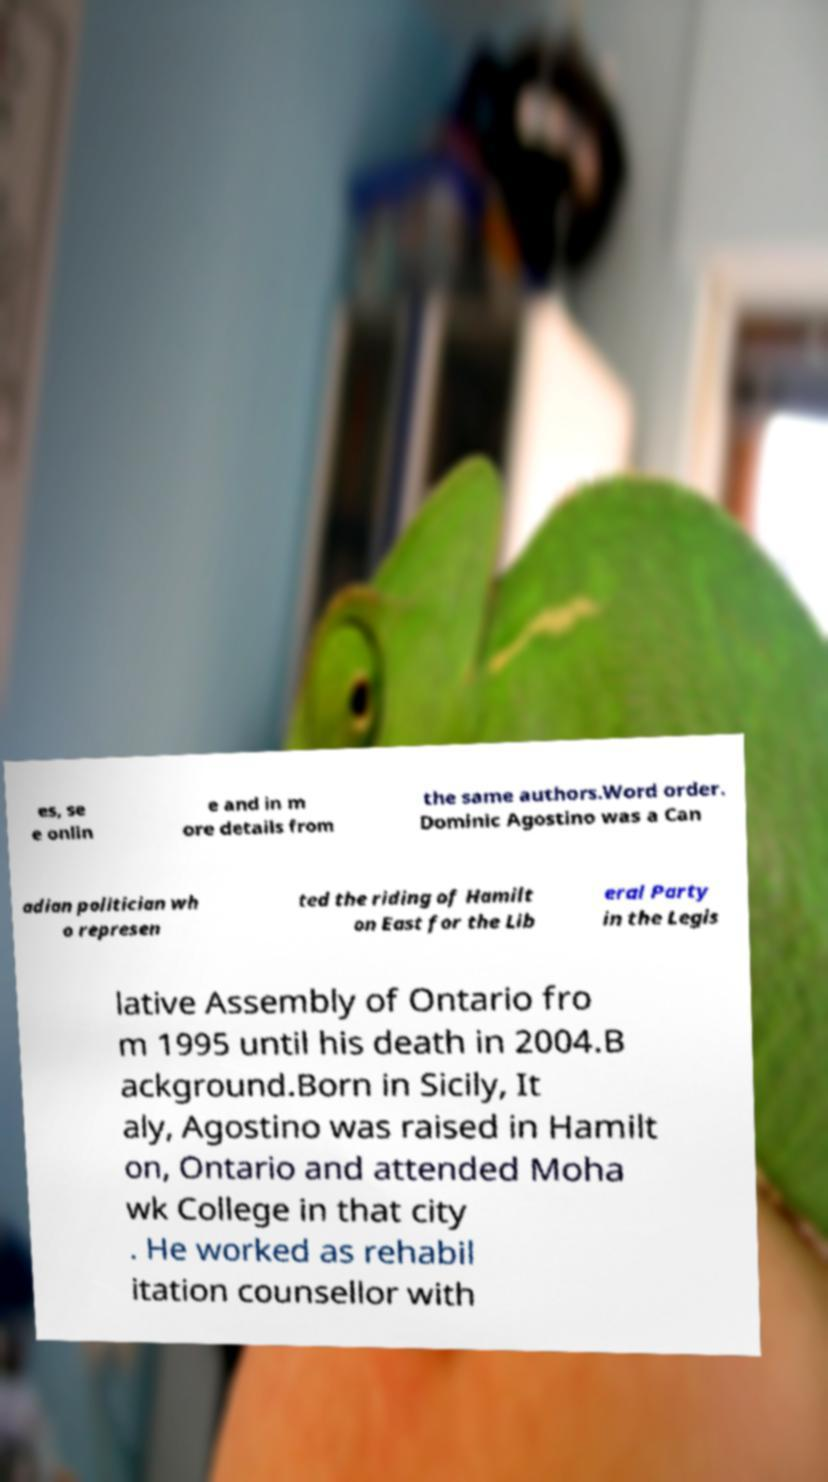Could you extract and type out the text from this image? es, se e onlin e and in m ore details from the same authors.Word order. Dominic Agostino was a Can adian politician wh o represen ted the riding of Hamilt on East for the Lib eral Party in the Legis lative Assembly of Ontario fro m 1995 until his death in 2004.B ackground.Born in Sicily, It aly, Agostino was raised in Hamilt on, Ontario and attended Moha wk College in that city . He worked as rehabil itation counsellor with 